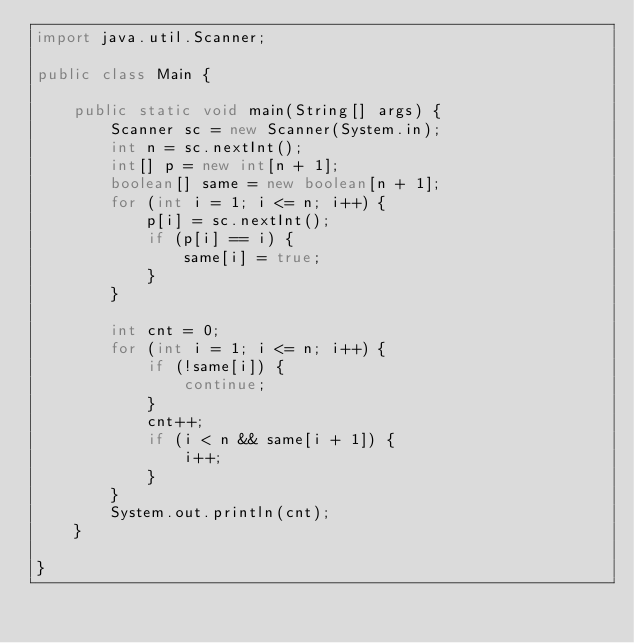Convert code to text. <code><loc_0><loc_0><loc_500><loc_500><_Java_>import java.util.Scanner;

public class Main {

    public static void main(String[] args) {
        Scanner sc = new Scanner(System.in);
        int n = sc.nextInt();
        int[] p = new int[n + 1];
        boolean[] same = new boolean[n + 1];
        for (int i = 1; i <= n; i++) {
            p[i] = sc.nextInt();
            if (p[i] == i) {
                same[i] = true;
            }
        }

        int cnt = 0;
        for (int i = 1; i <= n; i++) {
            if (!same[i]) {
                continue;
            }
            cnt++;
            if (i < n && same[i + 1]) {
                i++;
            }
        }
        System.out.println(cnt);
    }

}
</code> 